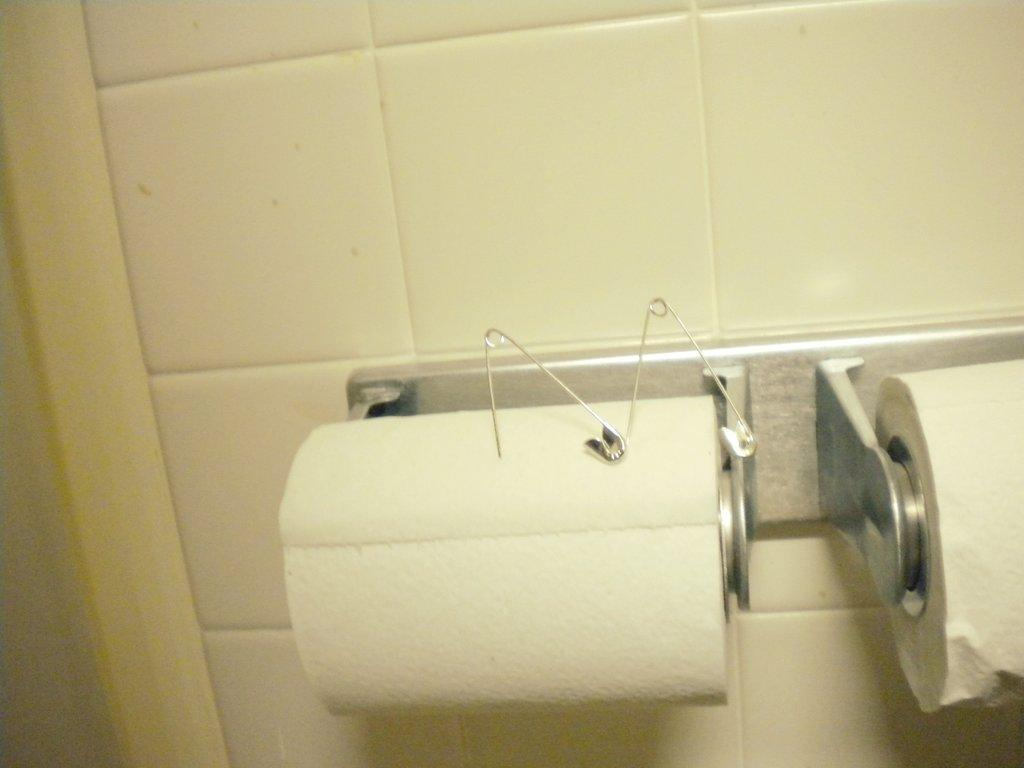What objects are present on the paper rolls in the image? There are safety pins on the paper rolls in the image. What type of material is the wall made up of in the image? The wall in the image is made up of tiles. What time does the alarm go off in the image? There is no alarm present in the image. What part of the body is visible in the image? There are no body parts visible in the image; it features paper rolls with safety pins and a tiled wall. 